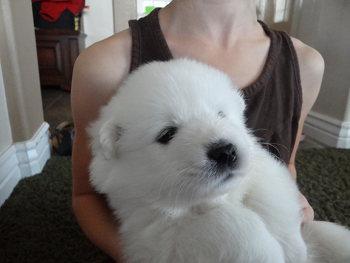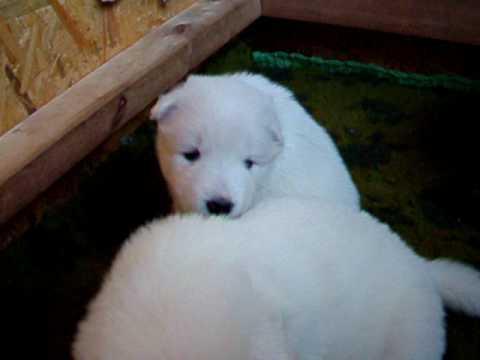The first image is the image on the left, the second image is the image on the right. Assess this claim about the two images: "One of the white dogs is awake and with a person.". Correct or not? Answer yes or no. Yes. The first image is the image on the left, the second image is the image on the right. Analyze the images presented: Is the assertion "one of the pictures has a human arm in it" valid? Answer yes or no. Yes. 